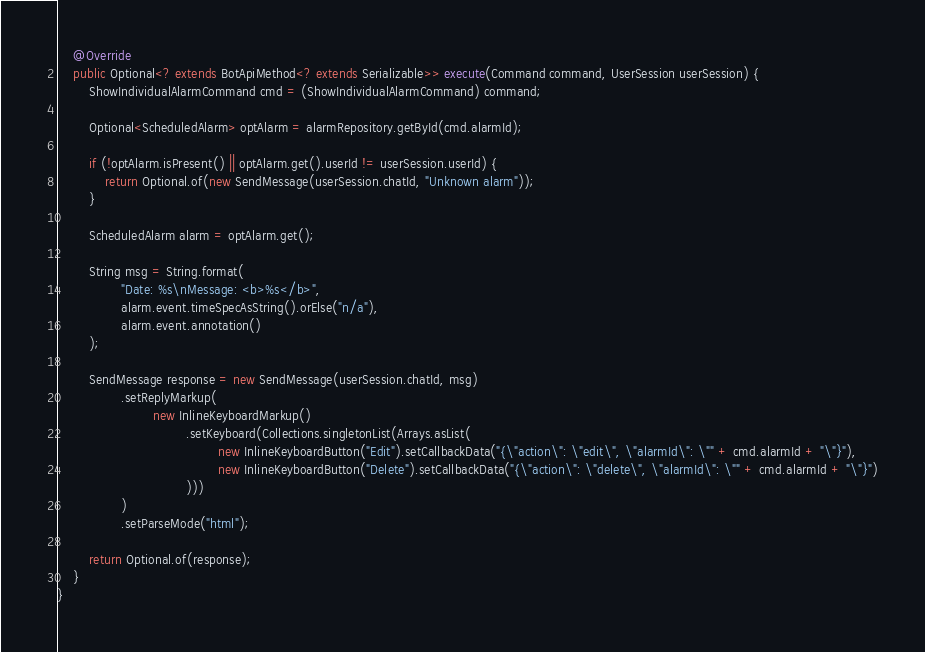Convert code to text. <code><loc_0><loc_0><loc_500><loc_500><_Java_>    @Override
    public Optional<? extends BotApiMethod<? extends Serializable>> execute(Command command, UserSession userSession) {
        ShowIndividualAlarmCommand cmd = (ShowIndividualAlarmCommand) command;

        Optional<ScheduledAlarm> optAlarm = alarmRepository.getById(cmd.alarmId);

        if (!optAlarm.isPresent() || optAlarm.get().userId != userSession.userId) {
            return Optional.of(new SendMessage(userSession.chatId, "Unknown alarm"));
        }

        ScheduledAlarm alarm = optAlarm.get();

        String msg = String.format(
                "Date: %s\nMessage: <b>%s</b>",
                alarm.event.timeSpecAsString().orElse("n/a"),
                alarm.event.annotation()
        );

        SendMessage response = new SendMessage(userSession.chatId, msg)
                .setReplyMarkup(
                        new InlineKeyboardMarkup()
                                .setKeyboard(Collections.singletonList(Arrays.asList(
                                        new InlineKeyboardButton("Edit").setCallbackData("{\"action\": \"edit\", \"alarmId\": \"" + cmd.alarmId + "\"}"),
                                        new InlineKeyboardButton("Delete").setCallbackData("{\"action\": \"delete\", \"alarmId\": \"" + cmd.alarmId + "\"}")
                                )))
                )
                .setParseMode("html");

        return Optional.of(response);
    }
}
</code> 